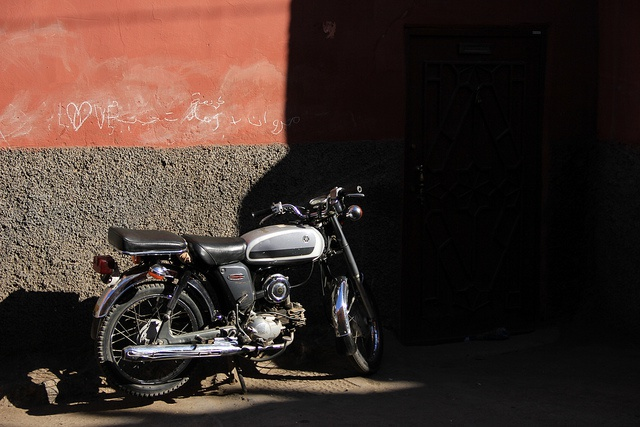Describe the objects in this image and their specific colors. I can see a motorcycle in salmon, black, gray, darkgray, and lightgray tones in this image. 